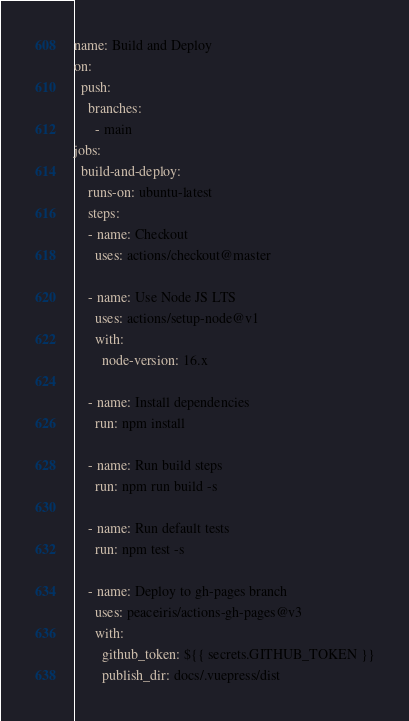<code> <loc_0><loc_0><loc_500><loc_500><_YAML_>name: Build and Deploy
on: 
  push:
    branches:
      - main
jobs:
  build-and-deploy:
    runs-on: ubuntu-latest
    steps:
    - name: Checkout
      uses: actions/checkout@master

    - name: Use Node JS LTS
      uses: actions/setup-node@v1
      with:
        node-version: 16.x
        
    - name: Install dependencies
      run: npm install

    - name: Run build steps
      run: npm run build -s

    - name: Run default tests
      run: npm test -s

    - name: Deploy to gh-pages branch
      uses: peaceiris/actions-gh-pages@v3
      with:
        github_token: ${{ secrets.GITHUB_TOKEN }}
        publish_dir: docs/.vuepress/dist
</code> 